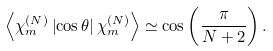<formula> <loc_0><loc_0><loc_500><loc_500>\left \langle \chi _ { m } ^ { ( N ) } \left | \cos \theta \right | \chi _ { m } ^ { ( N ) } \right \rangle \simeq \cos \left ( \frac { \pi } { N + 2 } \right ) .</formula> 